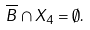Convert formula to latex. <formula><loc_0><loc_0><loc_500><loc_500>\overline { B } \cap X _ { 4 } = \emptyset .</formula> 